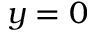Convert formula to latex. <formula><loc_0><loc_0><loc_500><loc_500>y = 0</formula> 